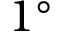<formula> <loc_0><loc_0><loc_500><loc_500>1 ^ { \circ }</formula> 